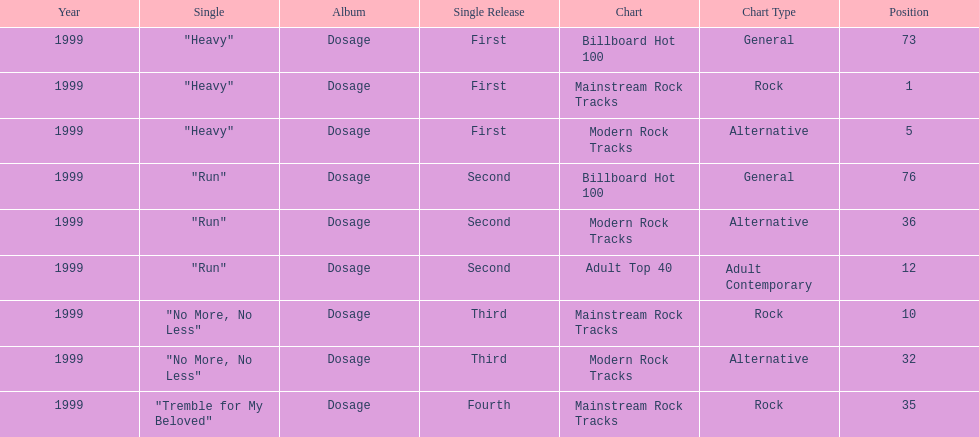Can you give me this table as a dict? {'header': ['Year', 'Single', 'Album', 'Single Release', 'Chart', 'Chart Type', 'Position'], 'rows': [['1999', '"Heavy"', 'Dosage', 'First', 'Billboard Hot 100', 'General', '73'], ['1999', '"Heavy"', 'Dosage', 'First', 'Mainstream Rock Tracks', 'Rock', '1'], ['1999', '"Heavy"', 'Dosage', 'First', 'Modern Rock Tracks', 'Alternative', '5'], ['1999', '"Run"', 'Dosage', 'Second', 'Billboard Hot 100', 'General', '76'], ['1999', '"Run"', 'Dosage', 'Second', 'Modern Rock Tracks', 'Alternative', '36'], ['1999', '"Run"', 'Dosage', 'Second', 'Adult Top 40', 'Adult Contemporary', '12'], ['1999', '"No More, No Less"', 'Dosage', 'Third', 'Mainstream Rock Tracks', 'Rock', '10'], ['1999', '"No More, No Less"', 'Dosage', 'Third', 'Modern Rock Tracks', 'Alternative', '32'], ['1999', '"Tremble for My Beloved"', 'Dosage', 'Fourth', 'Mainstream Rock Tracks', 'Rock', '35']]} How many different charts did "run" make? 3. 